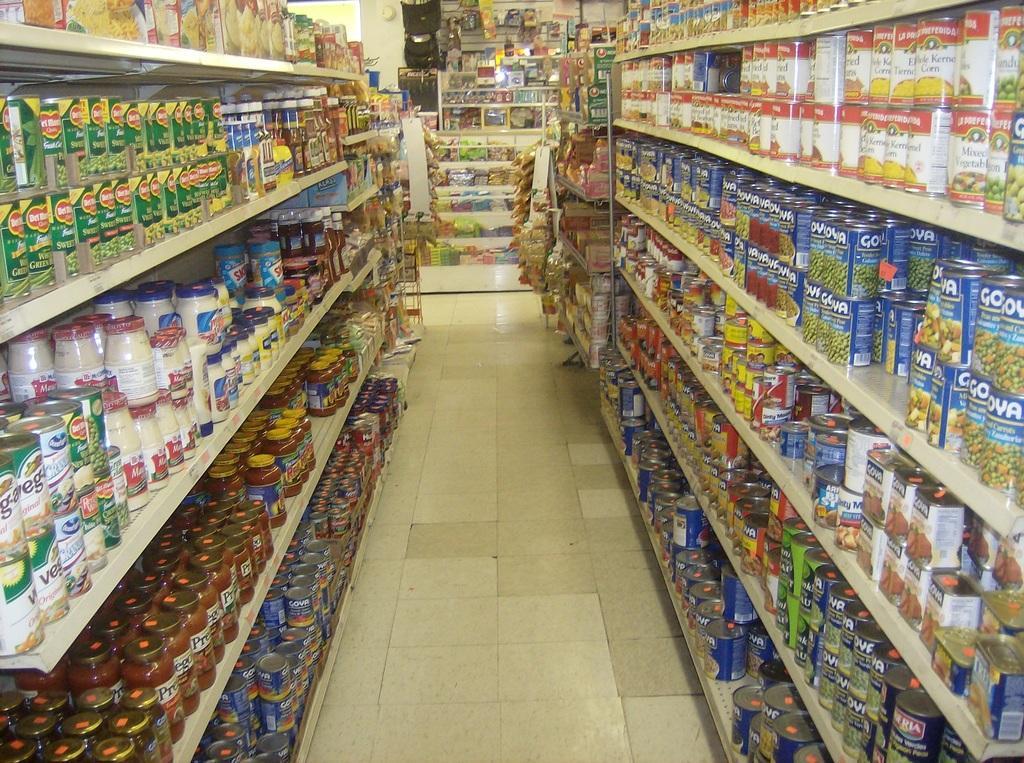Can you describe this image briefly? In this picture we can see racks, bottles, and food items. This is floor. 